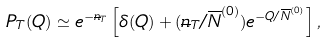<formula> <loc_0><loc_0><loc_500><loc_500>P _ { T } ( Q ) \simeq e ^ { - { \overline { n } } _ { T } } \left [ \delta ( Q ) + ( { \overline { n } } _ { T } / \overline { N } ^ { ( 0 ) } ) e ^ { - { Q / { \overline { N } } ^ { ( 0 ) } } } \right ] ,</formula> 